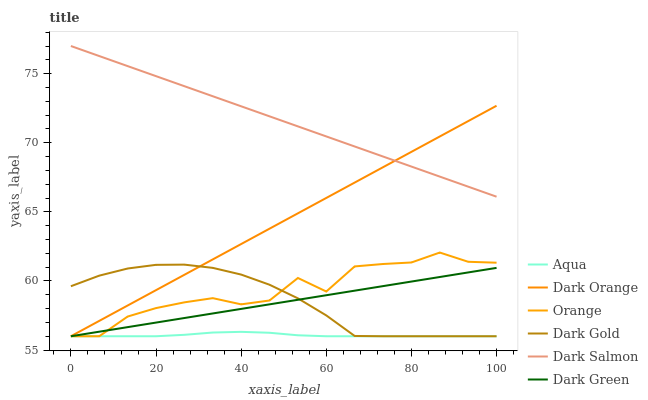Does Aqua have the minimum area under the curve?
Answer yes or no. Yes. Does Dark Salmon have the maximum area under the curve?
Answer yes or no. Yes. Does Dark Gold have the minimum area under the curve?
Answer yes or no. No. Does Dark Gold have the maximum area under the curve?
Answer yes or no. No. Is Dark Orange the smoothest?
Answer yes or no. Yes. Is Orange the roughest?
Answer yes or no. Yes. Is Dark Gold the smoothest?
Answer yes or no. No. Is Dark Gold the roughest?
Answer yes or no. No. Does Dark Orange have the lowest value?
Answer yes or no. Yes. Does Dark Salmon have the lowest value?
Answer yes or no. No. Does Dark Salmon have the highest value?
Answer yes or no. Yes. Does Dark Gold have the highest value?
Answer yes or no. No. Is Dark Green less than Dark Salmon?
Answer yes or no. Yes. Is Dark Salmon greater than Dark Gold?
Answer yes or no. Yes. Does Dark Green intersect Orange?
Answer yes or no. Yes. Is Dark Green less than Orange?
Answer yes or no. No. Is Dark Green greater than Orange?
Answer yes or no. No. Does Dark Green intersect Dark Salmon?
Answer yes or no. No. 